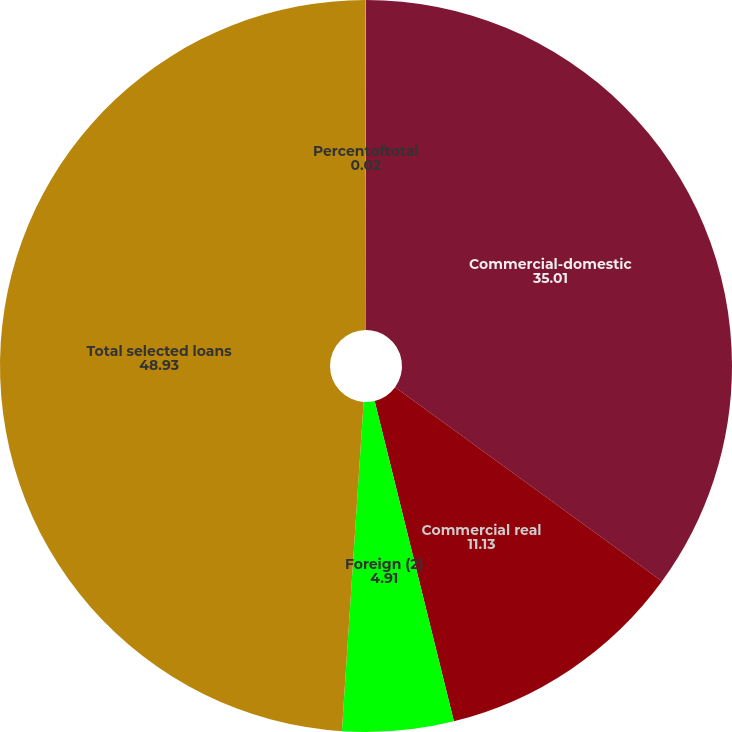<chart> <loc_0><loc_0><loc_500><loc_500><pie_chart><fcel>Commercial-domestic<fcel>Commercial real<fcel>Foreign (2)<fcel>Total selected loans<fcel>Percentoftotal<nl><fcel>35.01%<fcel>11.13%<fcel>4.91%<fcel>48.93%<fcel>0.02%<nl></chart> 